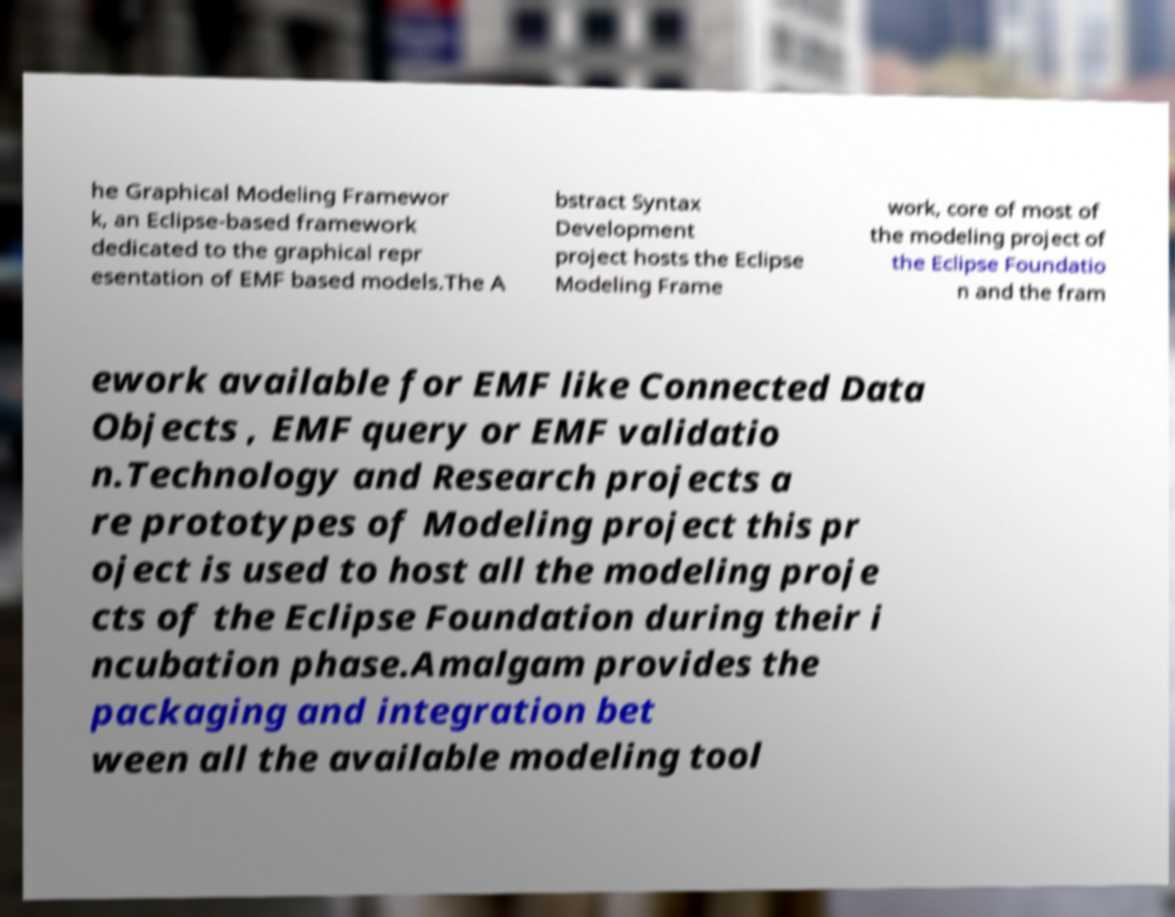Please read and relay the text visible in this image. What does it say? he Graphical Modeling Framewor k, an Eclipse-based framework dedicated to the graphical repr esentation of EMF based models.The A bstract Syntax Development project hosts the Eclipse Modeling Frame work, core of most of the modeling project of the Eclipse Foundatio n and the fram ework available for EMF like Connected Data Objects , EMF query or EMF validatio n.Technology and Research projects a re prototypes of Modeling project this pr oject is used to host all the modeling proje cts of the Eclipse Foundation during their i ncubation phase.Amalgam provides the packaging and integration bet ween all the available modeling tool 